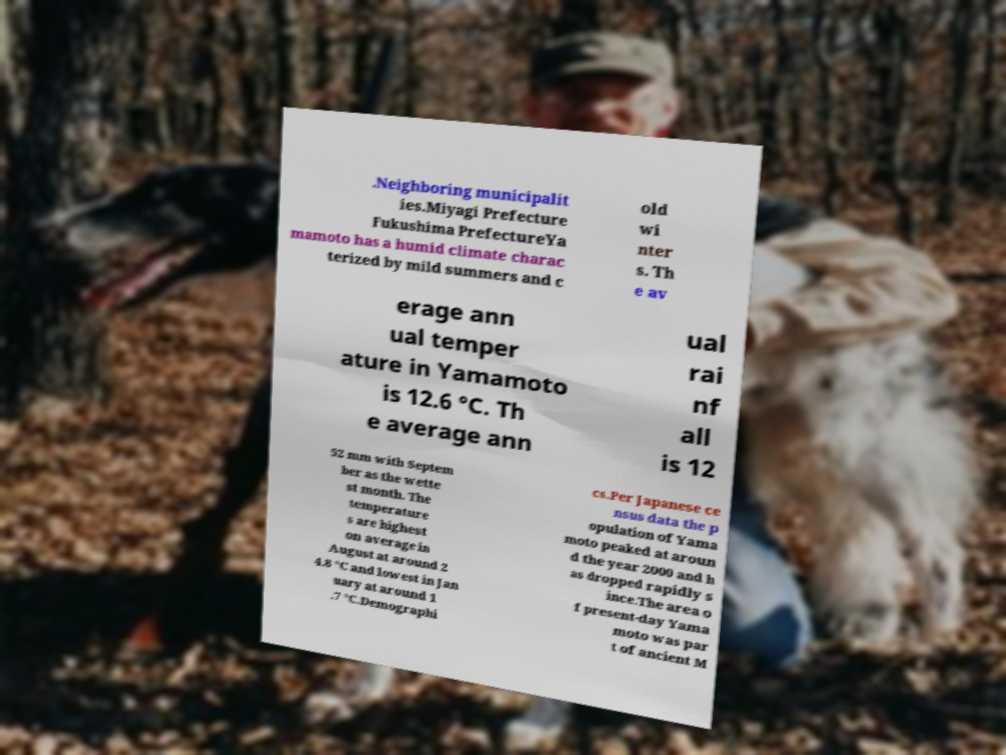Please identify and transcribe the text found in this image. .Neighboring municipalit ies.Miyagi Prefecture Fukushima PrefectureYa mamoto has a humid climate charac terized by mild summers and c old wi nter s. Th e av erage ann ual temper ature in Yamamoto is 12.6 °C. Th e average ann ual rai nf all is 12 52 mm with Septem ber as the wette st month. The temperature s are highest on average in August at around 2 4.8 °C and lowest in Jan uary at around 1 .7 °C.Demographi cs.Per Japanese ce nsus data the p opulation of Yama moto peaked at aroun d the year 2000 and h as dropped rapidly s ince.The area o f present-day Yama moto was par t of ancient M 